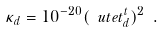Convert formula to latex. <formula><loc_0><loc_0><loc_500><loc_500>\kappa _ { d } = 1 0 ^ { - 2 0 } ( \ u t e t _ { d } ^ { t } ) ^ { 2 } \ .</formula> 